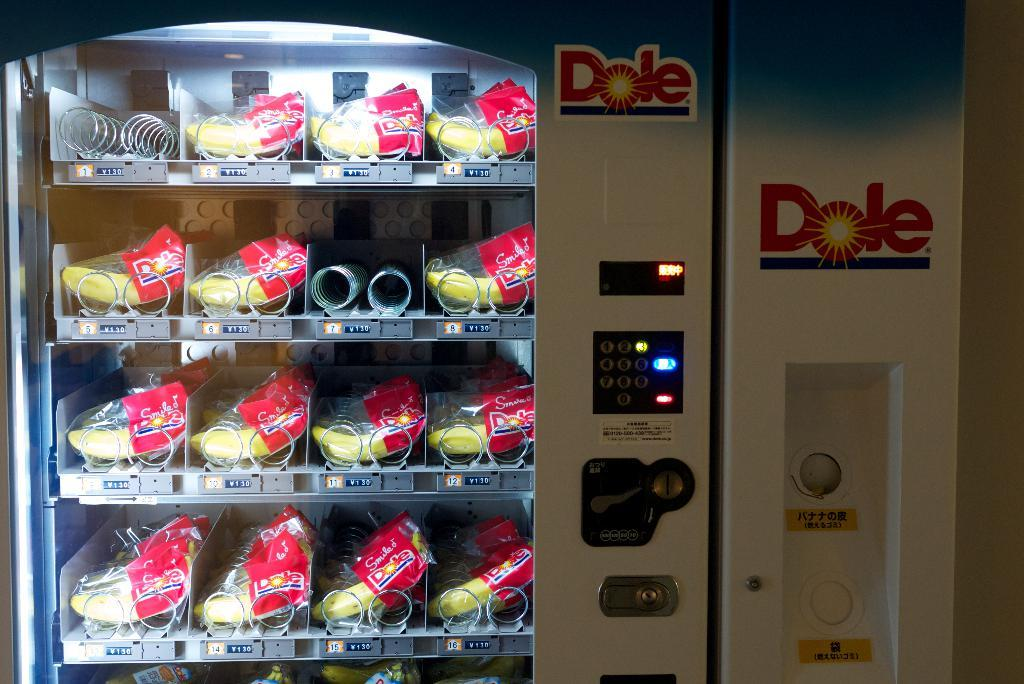What is the main object in the image? There is a machine in the image. What features does the machine have? The machine has buttons, locks, and logos. What can be found inside the machine? There are racks with food items inside the machine. What letters does the father write to his child in the image? There is no father or letters present in the image; it features a machine with racks of food items. 